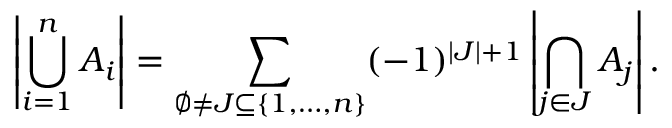Convert formula to latex. <formula><loc_0><loc_0><loc_500><loc_500>\left | \bigcup _ { i = 1 } ^ { n } A _ { i } \right | = \sum _ { \emptyset \neq J \subseteq \{ 1 , \dots , n \} } ( - 1 ) ^ { | J | + 1 } \left | \bigcap _ { j \in J } A _ { j } \right | .</formula> 